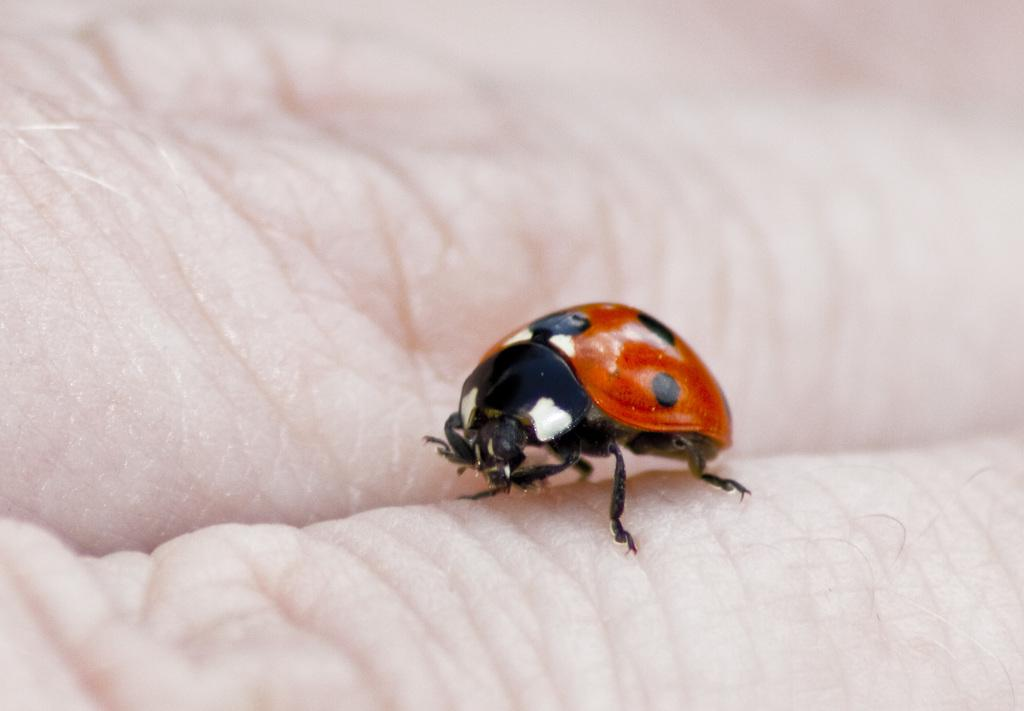What type of creature can be seen in the picture? There is an insect in the picture. Can you describe any other elements in the picture? Yes, there are fingers of a person visible in the picture. What type of pipe can be seen in the picture? There is no pipe present in the picture; it only features an insect and the fingers of a person. 